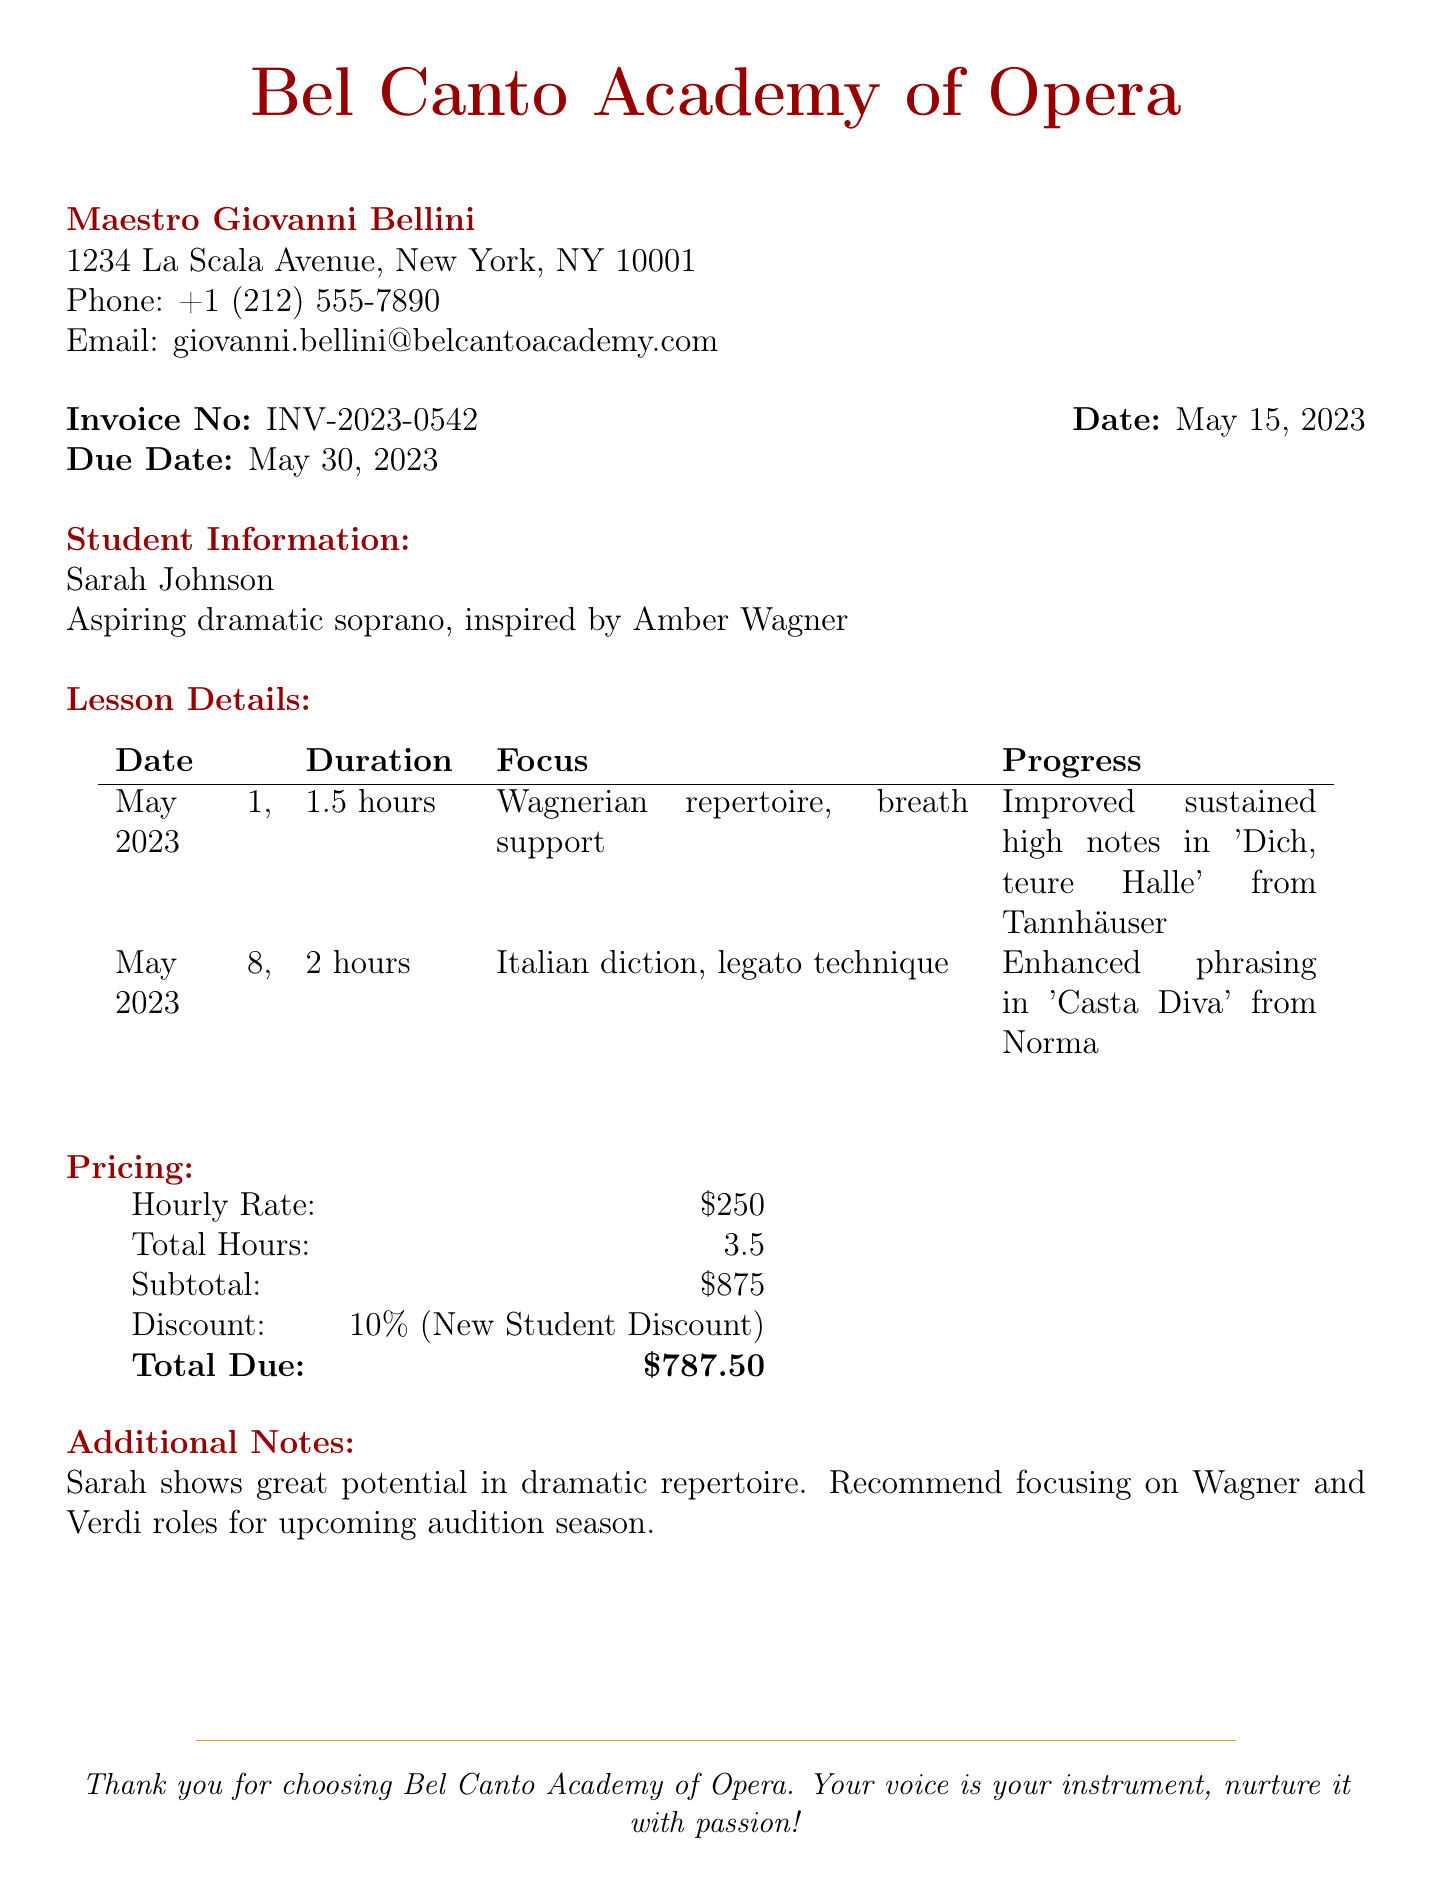What is the name of the opera coach? The name of the opera coach is provided in the header of the invoice, which is Maestro Giovanni Bellini.
Answer: Maestro Giovanni Bellini What is the student's name? The student's name is listed under Student Information, which is Sarah Johnson.
Answer: Sarah Johnson What was the focus of the lesson on May 8, 2023? The focus of the lesson can be found in the Lesson Details section, which states "Italian diction, legato technique."
Answer: Italian diction, legato technique How much is the hourly rate for the lessons? The hourly rate is mentioned under Pricing as $250.
Answer: $250 What is the total amount due after the discount? The total amount due is calculated and presented in the Pricing section, which is $787.50.
Answer: $787.50 What percentage discount did the student receive? The discount percentage is specified in the Pricing section as 10%.
Answer: 10% How many total hours of lessons did Sarah take? The total hours of lessons are listed under Pricing, which adds up to 3.5 hours.
Answer: 3.5 What progression was noted for the May 1, 2023 lesson? The progression noted is recorded in the Lesson Details for May 1, stating "Improved sustained high notes in 'Dich, teure Halle' from Tannhäuser."
Answer: Improved sustained high notes in 'Dich, teure Halle' from Tannhäuser What is suggested for Sarah's upcoming audition season? The Additional Notes section suggests focusing on Wagner and Verdi roles for upcoming auditions.
Answer: Focusing on Wagner and Verdi roles 